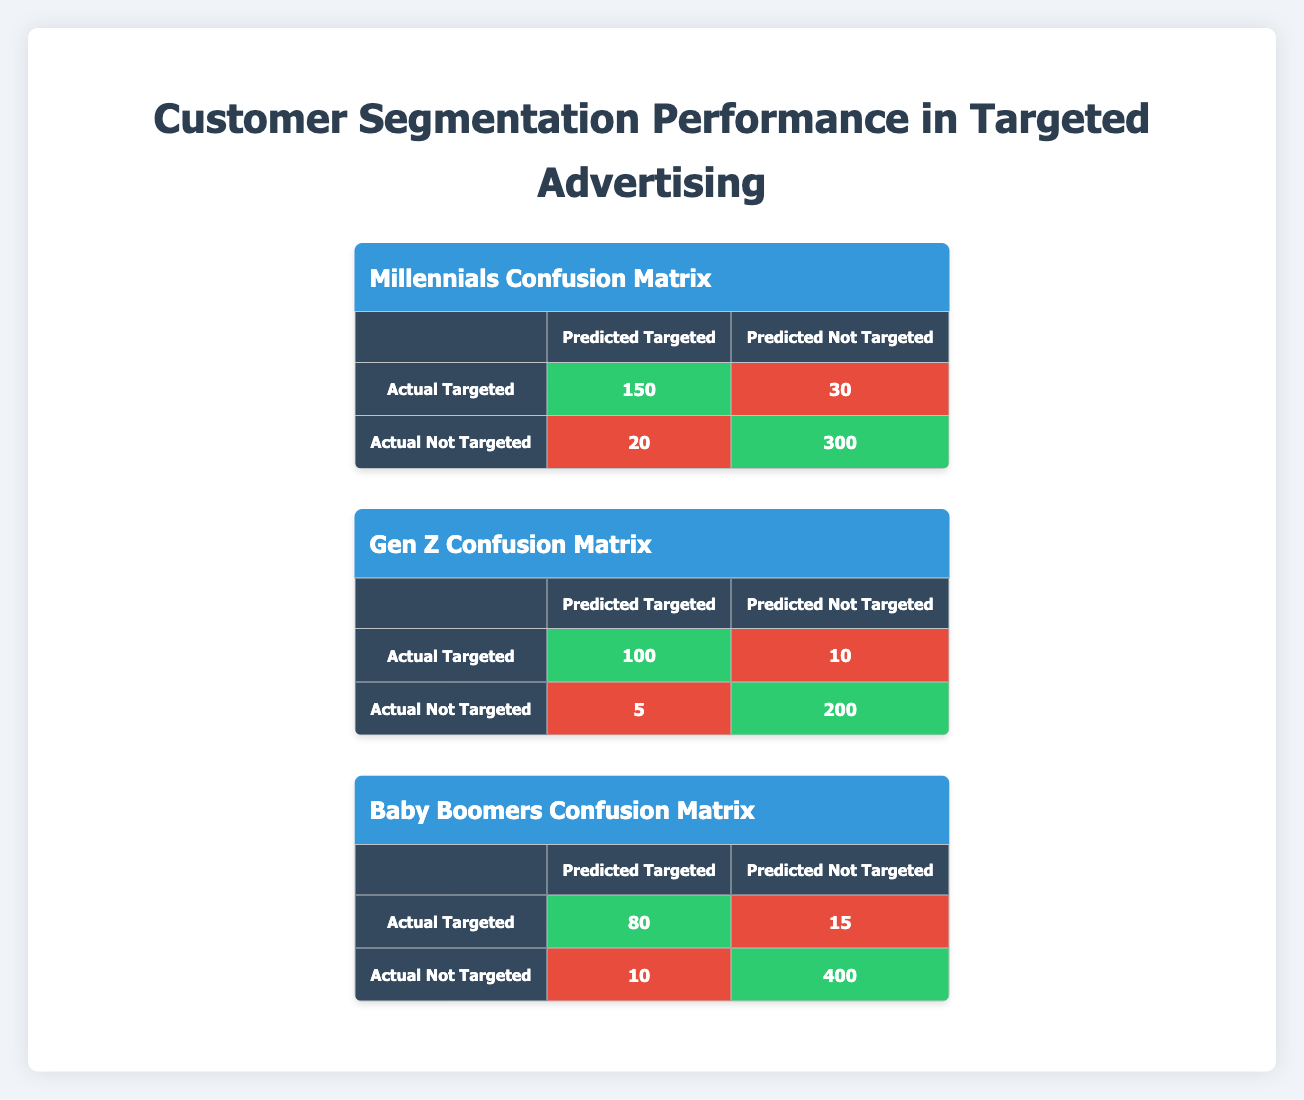What is the number of Millennials accurately predicted as Targeted? From the Millennials confusion matrix, the number of actual Targeted customers that were also predicted as Targeted is represented in the cell where Actual Targeted intersects with Predicted Targeted, which is 150.
Answer: 150 What is the total number of Gen Z customers who were not targeted? To find the total number of Gen Z customers who were not targeted, we look at the Actual Not Targeted row. There are 5 predicted as Targeted and 200 predicted as Not Targeted, totaling 5 + 200 = 205.
Answer: 205 How many Baby Boomers were misclassified as Targeted when they were actually Not Targeted? The number of Baby Boomers who were predicted Targeted but were actually Not Targeted is found in the Actual Not Targeted row intersecting with the Predicted Targeted column, which is 10.
Answer: 10 True or False: The number of Millennials correctly categorized as Not Targeted is greater than the number of Gen Z customers correctly categorized as Targeted. The number of Millennials accurately predicted as Not Targeted is 300 while the number of Gen Z accurately predicted as Targeted is 100. Since 300 is indeed greater than 100, the statement is true.
Answer: True What is the total number of customers for each segment that were actually Targeted? For Millennials, the total number is 150 + 30 = 180. For Gen Z, it is 100 + 10 = 110. For Baby Boomers, it's 80 + 15 = 95. Therefore, the totals are 180 for Millennials, 110 for Gen Z, and 95 for Baby Boomers.
Answer: Millennials: 180, Gen Z: 110, Baby Boomers: 95 How many Gen Z customers were classified correctly as Targeted and Not Targeted? The Gen Z customers classified correctly are 100 (Targeted) and 200 (Not Targeted). Adding these values gives us 100 + 200 = 300 correctly classified Gen Z customers.
Answer: 300 What is the total number of customers predicted as Not Targeted for all segments combined? To calculate this, we sum the counts in the Predicted Not Targeted column across all segments. For Millennials, it is 30 + 300 = 330; for Gen Z, it is 10 + 200 = 210; for Baby Boomers, it is 15 + 400 = 415. Adding these results gives us 330 + 210 + 415 = 955.
Answer: 955 True or False: The Baby Boomers segment had the highest count of Actual Targeted customers. Summing Baby Boomers' targeted counts, we get 80 (predicted as Targeted) and 15 (predicted as Not Targeted) for a total of 95, while the Millennials add up to 180 and Gen Z to 110. Since 180 is greater than 95, the statement is false.
Answer: False 